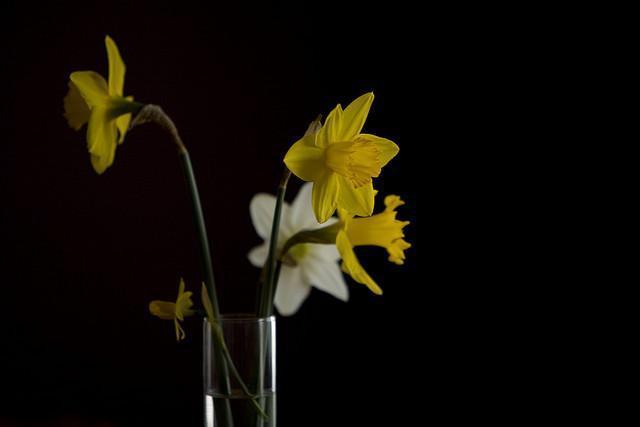How many flowers are in the vase?
Give a very brief answer. 5. 